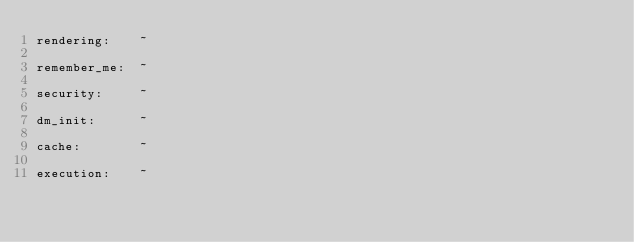Convert code to text. <code><loc_0><loc_0><loc_500><loc_500><_YAML_>rendering:    ~

remember_me:  ~

security:     ~

dm_init:      ~

cache:        ~

execution:    ~</code> 